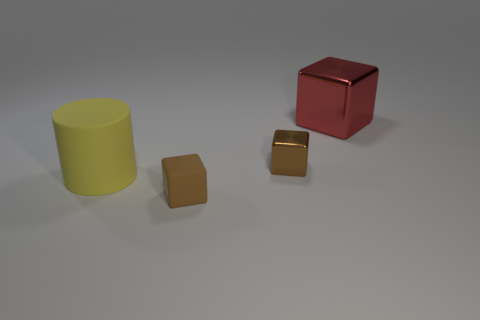Add 2 yellow rubber cylinders. How many objects exist? 6 Subtract all cubes. How many objects are left? 1 Add 3 big cylinders. How many big cylinders exist? 4 Subtract 0 red balls. How many objects are left? 4 Subtract all purple matte objects. Subtract all small rubber cubes. How many objects are left? 3 Add 3 small brown rubber blocks. How many small brown rubber blocks are left? 4 